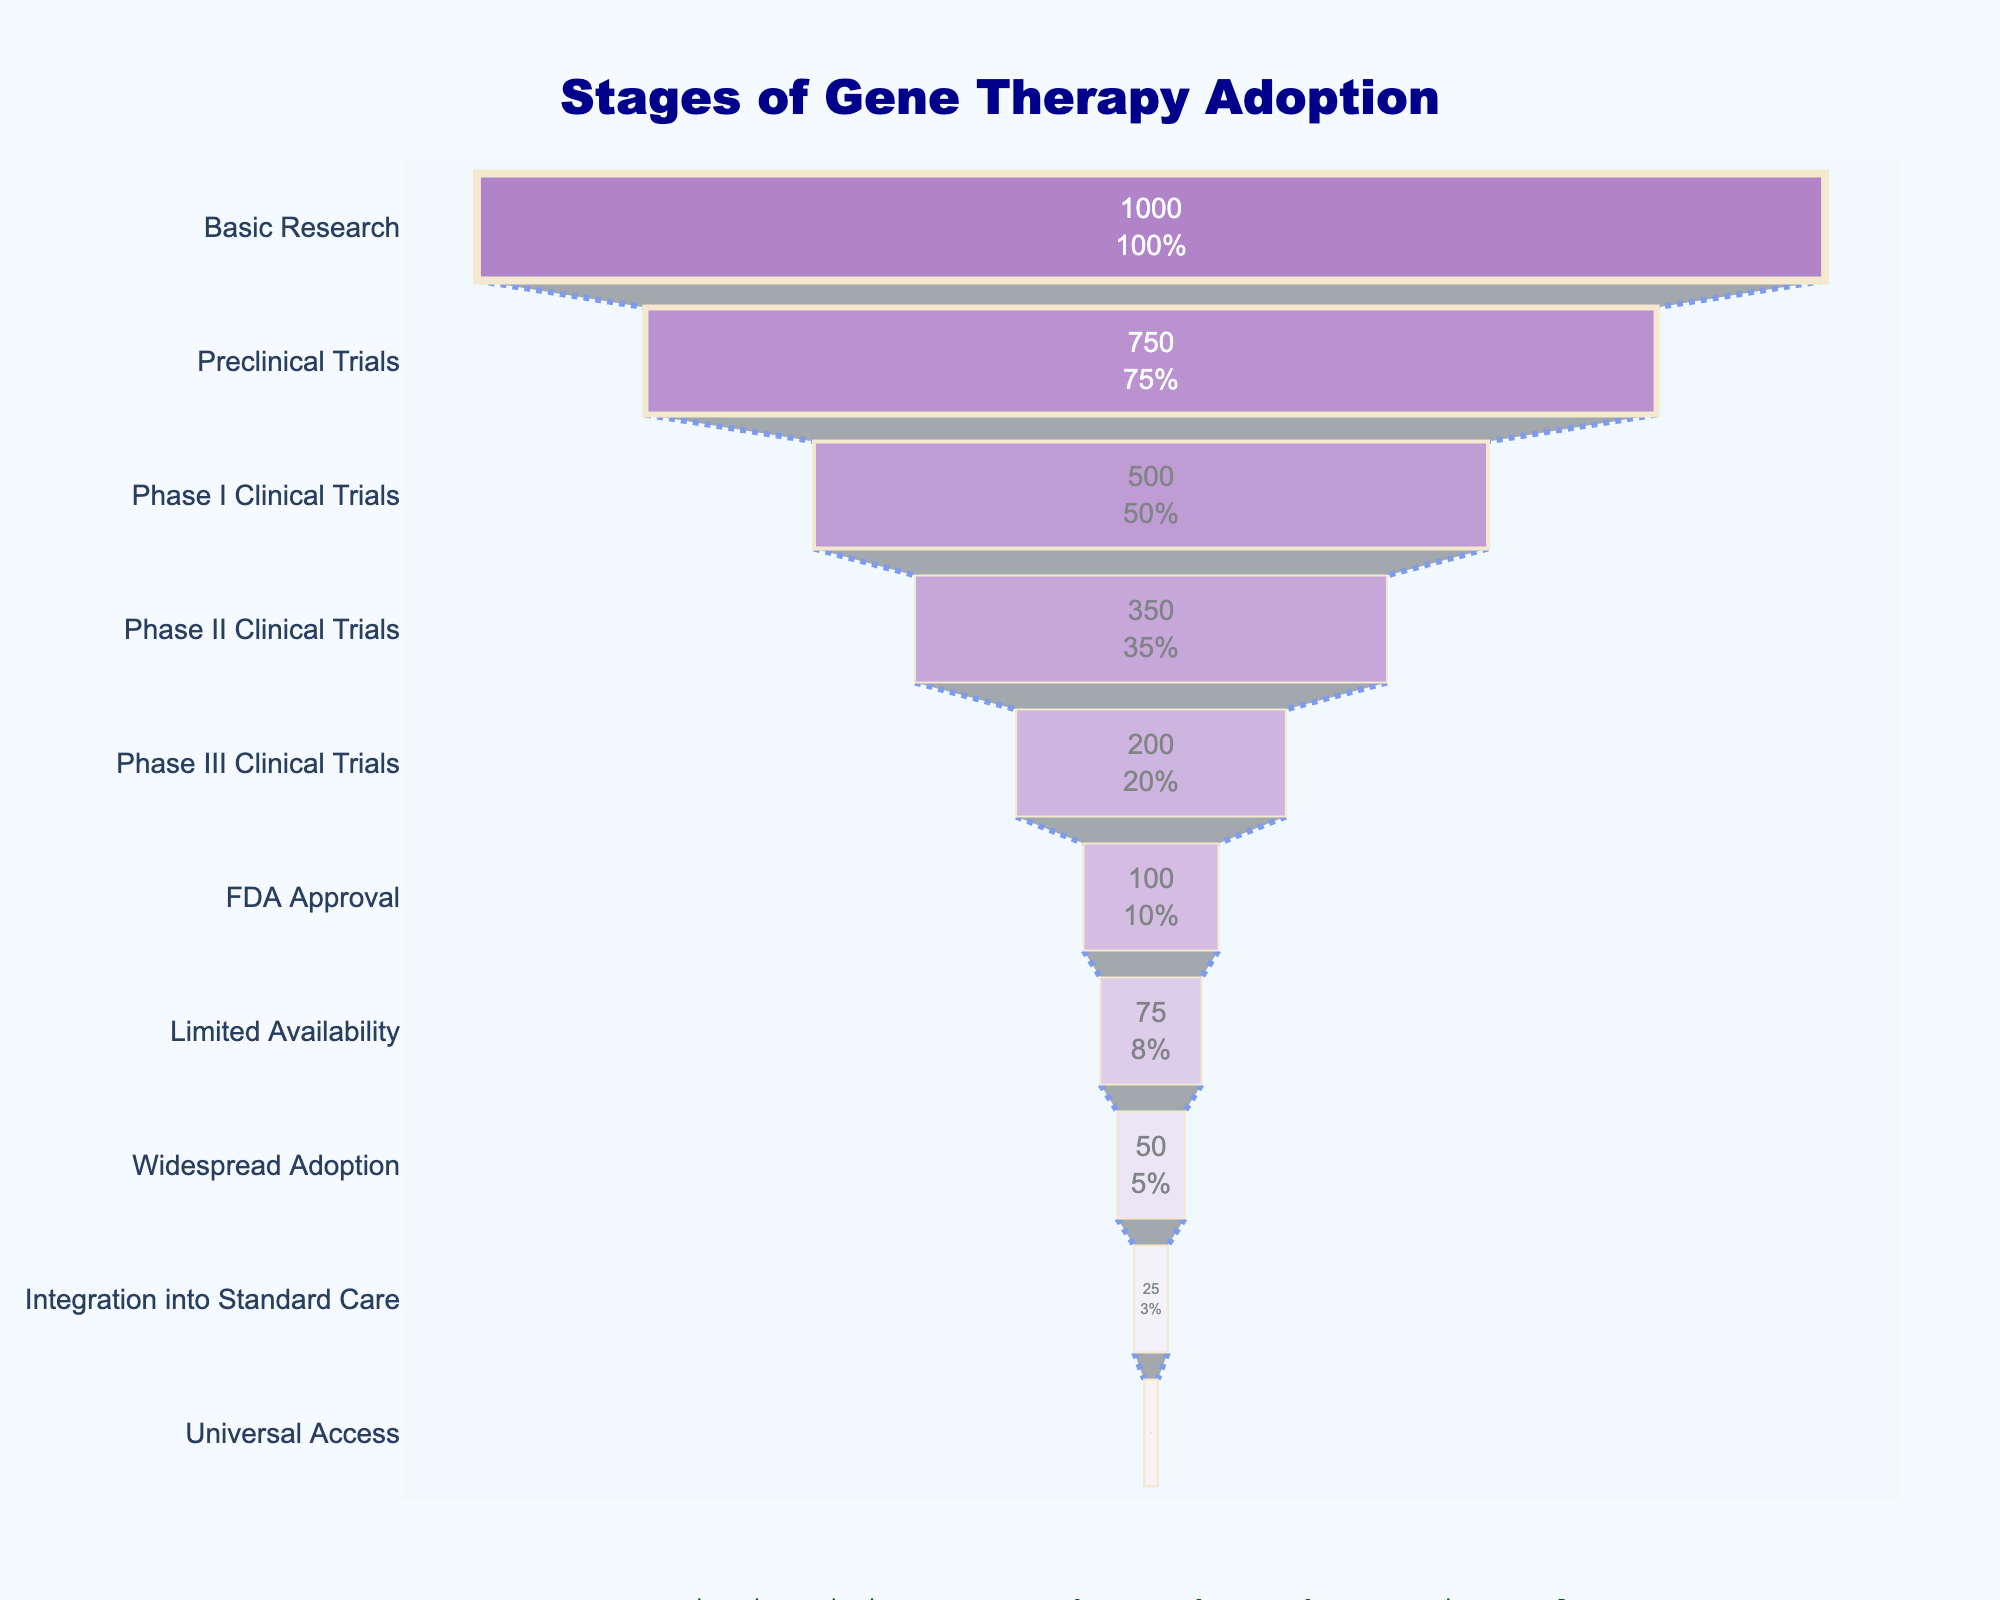What is the title of the chart? The title is located at the top center of the chart and is clearly displayed.
Answer: Stages of Gene Therapy Adoption How many stages are there from basic research to universal access? Count the number of different stages labeled on the y-axis.
Answer: 10 In which stage does gene therapy see the most significant drop in the number of treatments? Identify the stage with the largest decrease in the number of treatments as you move from the previous stage to the next stage. The drop from Basic Research (1000 treatments) to Preclinical Trials (750 treatments) is the largest since it is a drop of 250 treatments.
Answer: Basic Research to Preclinical Trials What's the cumulative number of treatments by the time a therapy reaches limited availability? Sum the treatments from Basic Research to Limited Availability: 1000 (Basic Research) + 750 (Preclinical Trials) + 500 (Phase I Clinical Trials) + 350 (Phase II Clinical Trials) + 200 (Phase III Clinical Trials) + 100 (FDA Approval) + 75 (Limited Availability) = 2975.
Answer: 2975 Which stage represents 10% of the treatments from the initial stage? Determine the stage where the number of treatments is 10% of the treatments in Basic Research, that is 10% of 1000 treatments (100 treatments). Universal Access has 10 treatments, which is 1% of the treatments at the Basic Research stage.
Answer: Universal Access How many stages are there before a treatment reaches FDA approval? Identify and count the number of stages before FDA Approval on the y-axis.
Answer: 5 What is the percentage of initial treatments that make it to widespread adoption? Widespread Adoption has 50 treatments. Calculate 50 as a percentage of the initial 1000 treatments: (50 / 1000) * 100 = 5%.
Answer: 5% Which stage has exactly half the number of treatments as the Preclinical Trials? Preclinical Trials has 750 treatments. Half of 750 is 375. Phase II Clinical Trials has 350 treatments, which is the closest to this value.
Answer: Phase II Clinical Trials Compare the number of treatments between Preclinical Trials and Phase III Clinical Trials. Which stage has more treatments? Compare the data: Preclinical Trials (750) vs. Phase III Clinical Trials (200). Clearly, Preclinical Trials has more treatments.
Answer: Preclinical Trials If a treatment makes it through Phase I Clinical Trials, what is the likelihood, in percentages, of it reaching FDA approval? Calculate the percentage by dividing the number of treatments in FDA Approval by Phase I Clinical Trials and multiply by 100. (100 / 500) * 100 = 20%.
Answer: 20% 